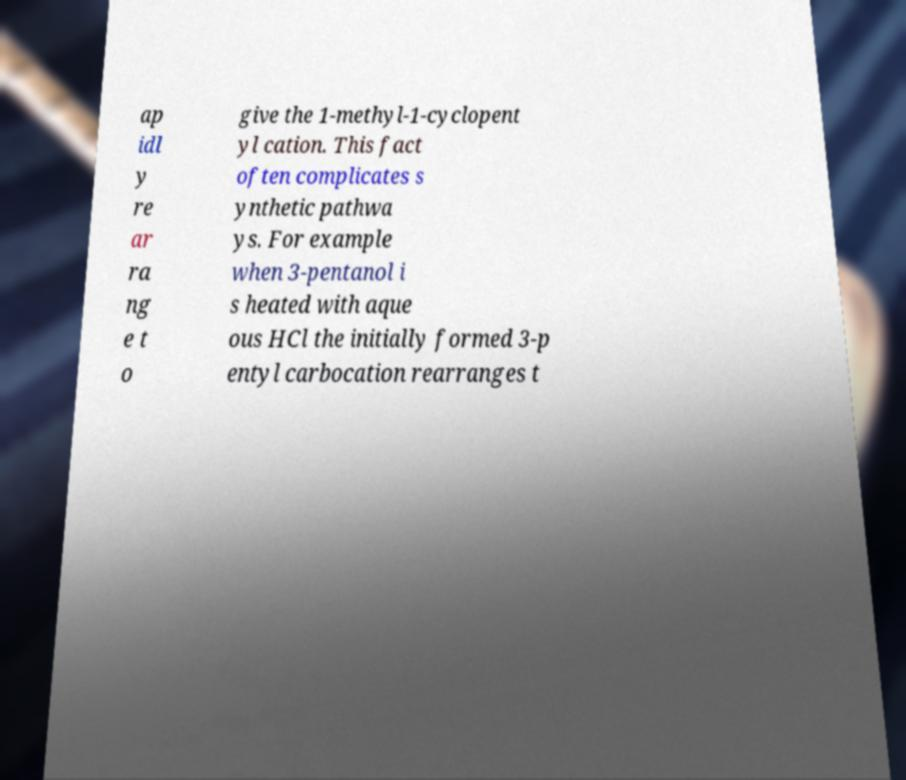Please identify and transcribe the text found in this image. ap idl y re ar ra ng e t o give the 1-methyl-1-cyclopent yl cation. This fact often complicates s ynthetic pathwa ys. For example when 3-pentanol i s heated with aque ous HCl the initially formed 3-p entyl carbocation rearranges t 